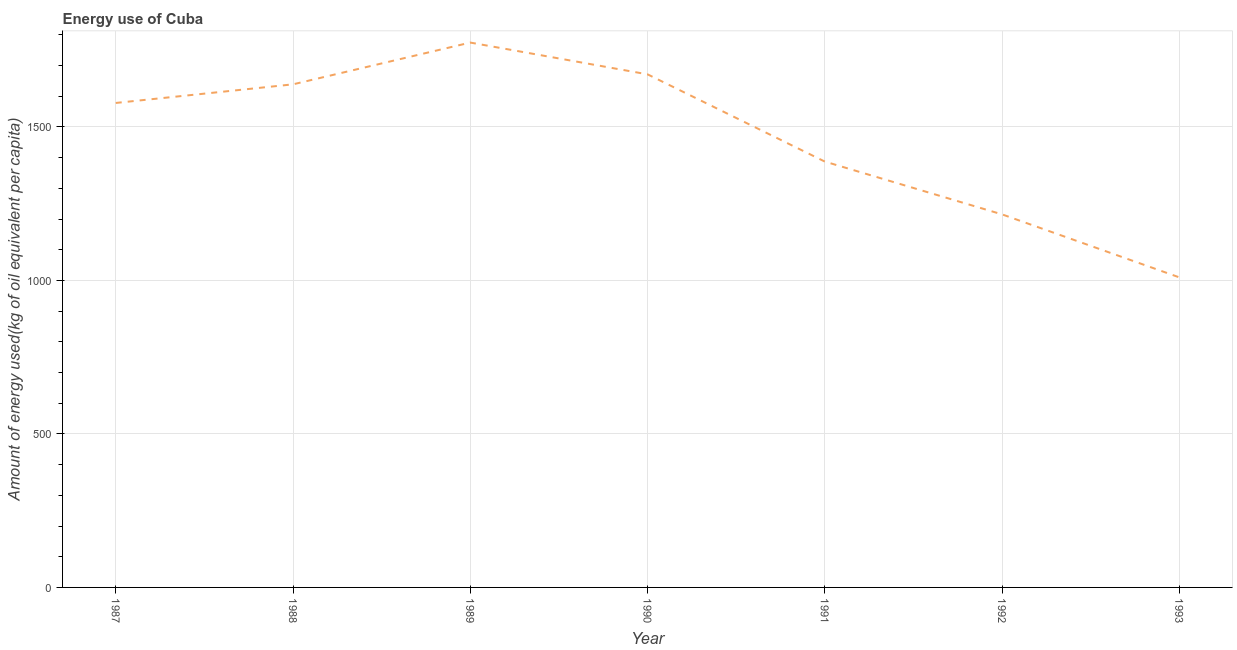What is the amount of energy used in 1987?
Offer a very short reply. 1578.26. Across all years, what is the maximum amount of energy used?
Provide a short and direct response. 1774.99. Across all years, what is the minimum amount of energy used?
Give a very brief answer. 1010.1. In which year was the amount of energy used maximum?
Provide a succinct answer. 1989. In which year was the amount of energy used minimum?
Ensure brevity in your answer.  1993. What is the sum of the amount of energy used?
Offer a very short reply. 1.03e+04. What is the difference between the amount of energy used in 1991 and 1993?
Your answer should be very brief. 377.22. What is the average amount of energy used per year?
Your response must be concise. 1468.06. What is the median amount of energy used?
Your answer should be compact. 1578.26. What is the ratio of the amount of energy used in 1987 to that in 1991?
Give a very brief answer. 1.14. Is the difference between the amount of energy used in 1987 and 1988 greater than the difference between any two years?
Your answer should be compact. No. What is the difference between the highest and the second highest amount of energy used?
Provide a succinct answer. 103.49. Is the sum of the amount of energy used in 1988 and 1990 greater than the maximum amount of energy used across all years?
Provide a short and direct response. Yes. What is the difference between the highest and the lowest amount of energy used?
Make the answer very short. 764.9. In how many years, is the amount of energy used greater than the average amount of energy used taken over all years?
Your answer should be compact. 4. How many years are there in the graph?
Your response must be concise. 7. Are the values on the major ticks of Y-axis written in scientific E-notation?
Provide a short and direct response. No. What is the title of the graph?
Provide a succinct answer. Energy use of Cuba. What is the label or title of the Y-axis?
Offer a very short reply. Amount of energy used(kg of oil equivalent per capita). What is the Amount of energy used(kg of oil equivalent per capita) in 1987?
Your answer should be compact. 1578.26. What is the Amount of energy used(kg of oil equivalent per capita) in 1988?
Offer a very short reply. 1638.95. What is the Amount of energy used(kg of oil equivalent per capita) of 1989?
Your response must be concise. 1774.99. What is the Amount of energy used(kg of oil equivalent per capita) of 1990?
Provide a short and direct response. 1671.51. What is the Amount of energy used(kg of oil equivalent per capita) of 1991?
Provide a short and direct response. 1387.31. What is the Amount of energy used(kg of oil equivalent per capita) of 1992?
Your response must be concise. 1215.27. What is the Amount of energy used(kg of oil equivalent per capita) in 1993?
Keep it short and to the point. 1010.1. What is the difference between the Amount of energy used(kg of oil equivalent per capita) in 1987 and 1988?
Keep it short and to the point. -60.69. What is the difference between the Amount of energy used(kg of oil equivalent per capita) in 1987 and 1989?
Provide a short and direct response. -196.73. What is the difference between the Amount of energy used(kg of oil equivalent per capita) in 1987 and 1990?
Give a very brief answer. -93.25. What is the difference between the Amount of energy used(kg of oil equivalent per capita) in 1987 and 1991?
Make the answer very short. 190.94. What is the difference between the Amount of energy used(kg of oil equivalent per capita) in 1987 and 1992?
Your answer should be very brief. 362.99. What is the difference between the Amount of energy used(kg of oil equivalent per capita) in 1987 and 1993?
Ensure brevity in your answer.  568.16. What is the difference between the Amount of energy used(kg of oil equivalent per capita) in 1988 and 1989?
Offer a terse response. -136.04. What is the difference between the Amount of energy used(kg of oil equivalent per capita) in 1988 and 1990?
Your answer should be very brief. -32.56. What is the difference between the Amount of energy used(kg of oil equivalent per capita) in 1988 and 1991?
Offer a terse response. 251.64. What is the difference between the Amount of energy used(kg of oil equivalent per capita) in 1988 and 1992?
Make the answer very short. 423.69. What is the difference between the Amount of energy used(kg of oil equivalent per capita) in 1988 and 1993?
Your answer should be compact. 628.86. What is the difference between the Amount of energy used(kg of oil equivalent per capita) in 1989 and 1990?
Ensure brevity in your answer.  103.49. What is the difference between the Amount of energy used(kg of oil equivalent per capita) in 1989 and 1991?
Provide a succinct answer. 387.68. What is the difference between the Amount of energy used(kg of oil equivalent per capita) in 1989 and 1992?
Offer a terse response. 559.73. What is the difference between the Amount of energy used(kg of oil equivalent per capita) in 1989 and 1993?
Ensure brevity in your answer.  764.9. What is the difference between the Amount of energy used(kg of oil equivalent per capita) in 1990 and 1991?
Keep it short and to the point. 284.19. What is the difference between the Amount of energy used(kg of oil equivalent per capita) in 1990 and 1992?
Provide a succinct answer. 456.24. What is the difference between the Amount of energy used(kg of oil equivalent per capita) in 1990 and 1993?
Provide a succinct answer. 661.41. What is the difference between the Amount of energy used(kg of oil equivalent per capita) in 1991 and 1992?
Ensure brevity in your answer.  172.05. What is the difference between the Amount of energy used(kg of oil equivalent per capita) in 1991 and 1993?
Provide a short and direct response. 377.22. What is the difference between the Amount of energy used(kg of oil equivalent per capita) in 1992 and 1993?
Your answer should be compact. 205.17. What is the ratio of the Amount of energy used(kg of oil equivalent per capita) in 1987 to that in 1989?
Offer a very short reply. 0.89. What is the ratio of the Amount of energy used(kg of oil equivalent per capita) in 1987 to that in 1990?
Your answer should be compact. 0.94. What is the ratio of the Amount of energy used(kg of oil equivalent per capita) in 1987 to that in 1991?
Your answer should be very brief. 1.14. What is the ratio of the Amount of energy used(kg of oil equivalent per capita) in 1987 to that in 1992?
Your response must be concise. 1.3. What is the ratio of the Amount of energy used(kg of oil equivalent per capita) in 1987 to that in 1993?
Your response must be concise. 1.56. What is the ratio of the Amount of energy used(kg of oil equivalent per capita) in 1988 to that in 1989?
Keep it short and to the point. 0.92. What is the ratio of the Amount of energy used(kg of oil equivalent per capita) in 1988 to that in 1991?
Ensure brevity in your answer.  1.18. What is the ratio of the Amount of energy used(kg of oil equivalent per capita) in 1988 to that in 1992?
Ensure brevity in your answer.  1.35. What is the ratio of the Amount of energy used(kg of oil equivalent per capita) in 1988 to that in 1993?
Offer a very short reply. 1.62. What is the ratio of the Amount of energy used(kg of oil equivalent per capita) in 1989 to that in 1990?
Your response must be concise. 1.06. What is the ratio of the Amount of energy used(kg of oil equivalent per capita) in 1989 to that in 1991?
Offer a terse response. 1.28. What is the ratio of the Amount of energy used(kg of oil equivalent per capita) in 1989 to that in 1992?
Provide a short and direct response. 1.46. What is the ratio of the Amount of energy used(kg of oil equivalent per capita) in 1989 to that in 1993?
Provide a succinct answer. 1.76. What is the ratio of the Amount of energy used(kg of oil equivalent per capita) in 1990 to that in 1991?
Give a very brief answer. 1.21. What is the ratio of the Amount of energy used(kg of oil equivalent per capita) in 1990 to that in 1992?
Your answer should be compact. 1.38. What is the ratio of the Amount of energy used(kg of oil equivalent per capita) in 1990 to that in 1993?
Offer a very short reply. 1.66. What is the ratio of the Amount of energy used(kg of oil equivalent per capita) in 1991 to that in 1992?
Your answer should be compact. 1.14. What is the ratio of the Amount of energy used(kg of oil equivalent per capita) in 1991 to that in 1993?
Ensure brevity in your answer.  1.37. What is the ratio of the Amount of energy used(kg of oil equivalent per capita) in 1992 to that in 1993?
Your response must be concise. 1.2. 